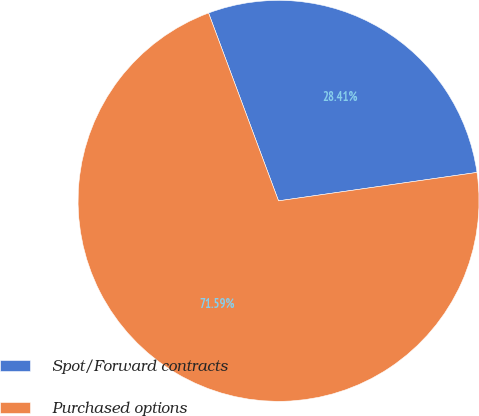<chart> <loc_0><loc_0><loc_500><loc_500><pie_chart><fcel>Spot/Forward contracts<fcel>Purchased options<nl><fcel>28.41%<fcel>71.59%<nl></chart> 